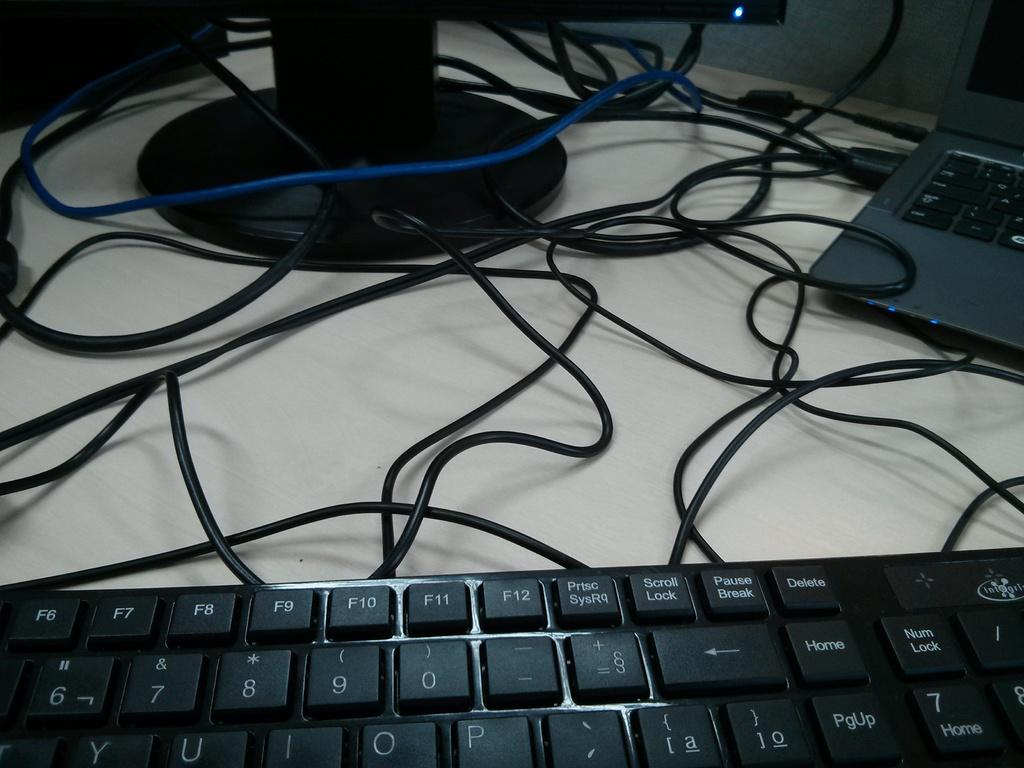<image>
Share a concise interpretation of the image provided. A keybord is in the foreground, on which the delete key is to the right of the pause break key. 